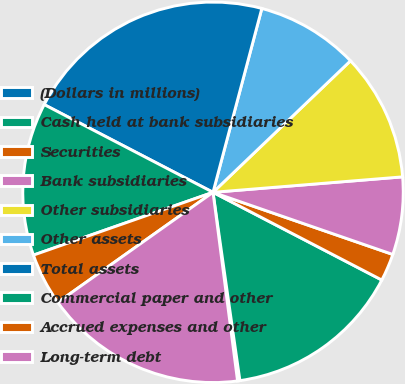<chart> <loc_0><loc_0><loc_500><loc_500><pie_chart><fcel>(Dollars in millions)<fcel>Cash held at bank subsidiaries<fcel>Securities<fcel>Bank subsidiaries<fcel>Other subsidiaries<fcel>Other assets<fcel>Total assets<fcel>Commercial paper and other<fcel>Accrued expenses and other<fcel>Long-term debt<nl><fcel>0.2%<fcel>15.11%<fcel>2.33%<fcel>6.59%<fcel>10.85%<fcel>8.72%<fcel>21.5%<fcel>12.98%<fcel>4.46%<fcel>17.24%<nl></chart> 